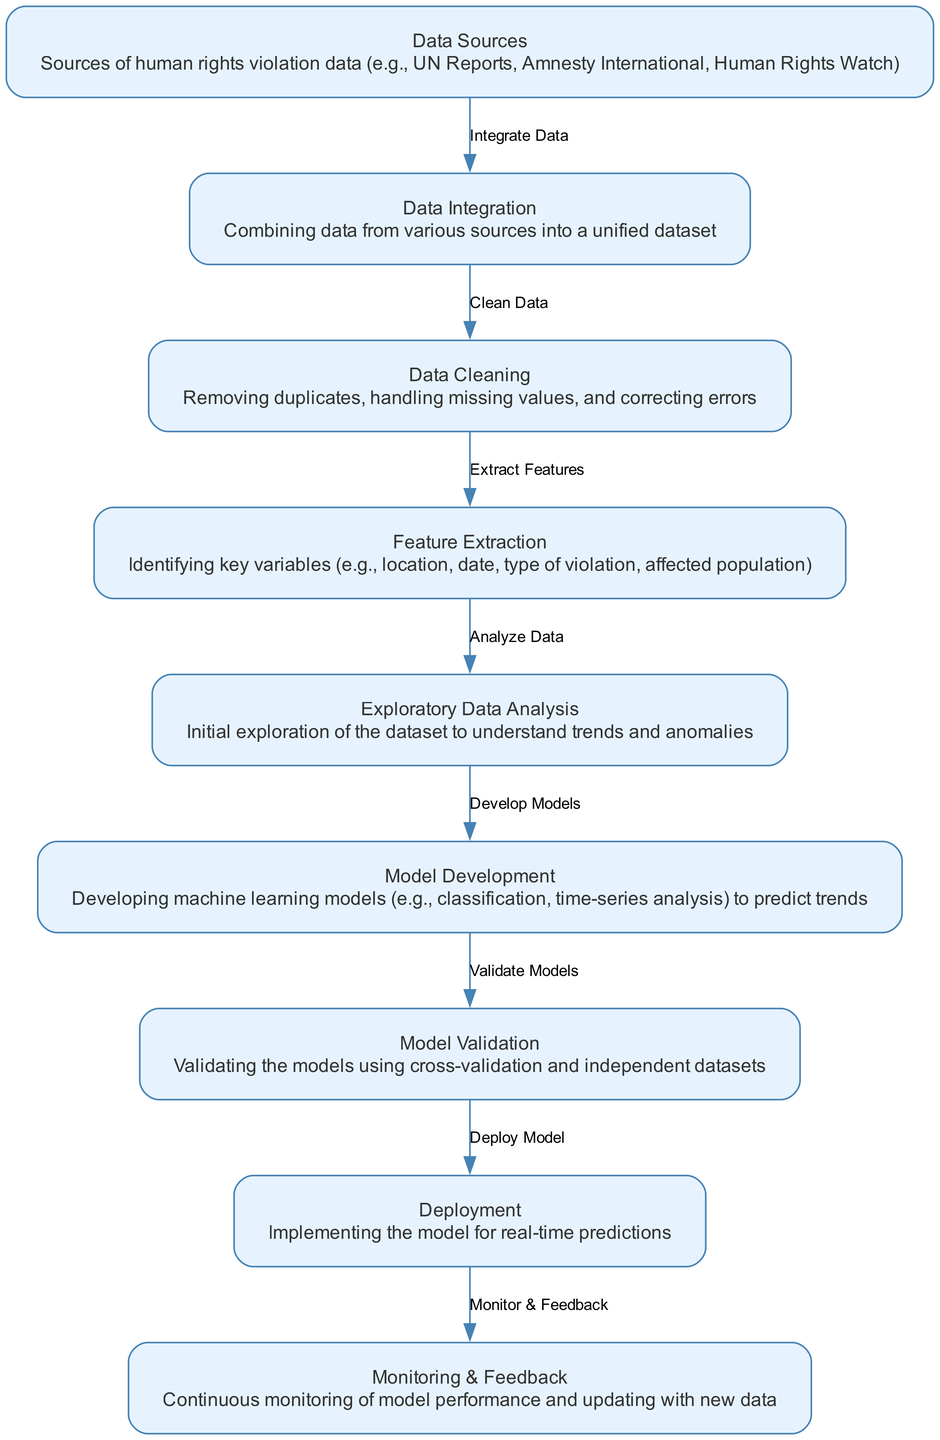What is the first step in the predictive analytics process? The first step is "Data Sources," where data from human rights violation sources is collected.
Answer: Data Sources How many nodes are present in this diagram? The diagram contains a total of nine nodes representing different stages of the predictive analytics process.
Answer: Nine What is the relationship between "Data Integration" and "Data Cleaning"? "Data Integration" leads to "Data Cleaning," indicating that data must be integrated before it can be cleaned.
Answer: Clean Data What is the last stage of the predictive analytics process? The last stage is "Monitoring & Feedback," focusing on the continuous monitoring and updating of the model.
Answer: Monitoring & Feedback Which node is directly connected to "Model Development"? The node directly connected to "Model Development" is "Exploratory Data Analysis," which is a step before model development to understand trends.
Answer: Exploratory Data Analysis How many edges are used in this diagram? The diagram uses eight edges to indicate the process flow between the various stages of predictive analytics.
Answer: Eight What is the purpose of "Feature Extraction"? The purpose of "Feature Extraction" is to identify key variables that will be used in further analysis and modeling.
Answer: Identifying key variables What is the outcome of "Model Validation"? The outcome of "Model Validation" is to ensure the developed models are reliable and accurate for making predictions.
Answer: Reliable and accurate models Which stage involves implementing the model for real-time predictions? The stage that involves implementing the model for real-time predictions is "Deployment."
Answer: Deployment 